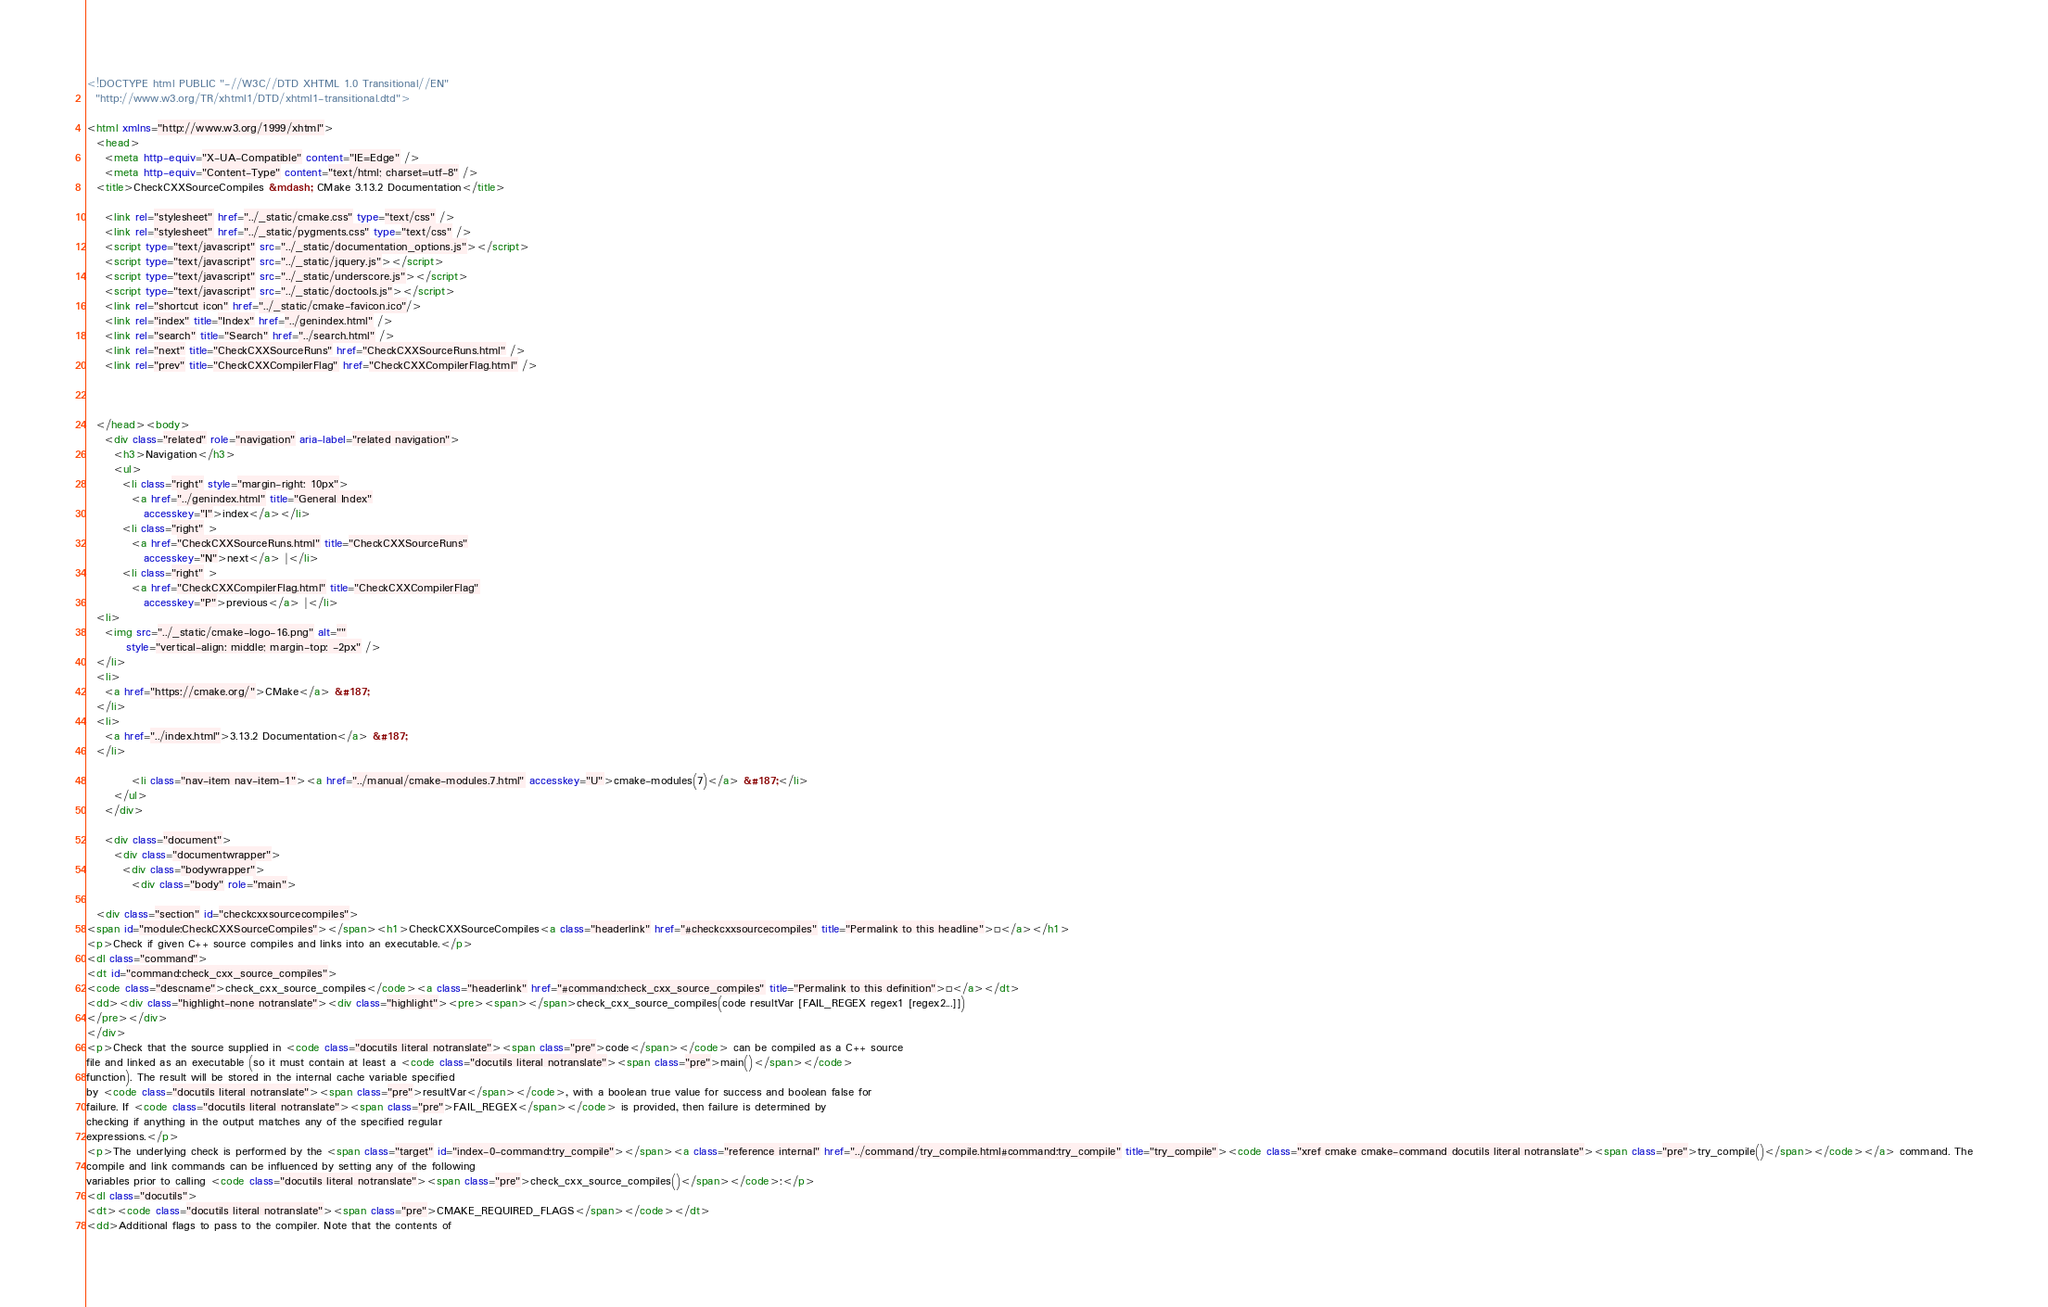Convert code to text. <code><loc_0><loc_0><loc_500><loc_500><_HTML_>
<!DOCTYPE html PUBLIC "-//W3C//DTD XHTML 1.0 Transitional//EN"
  "http://www.w3.org/TR/xhtml1/DTD/xhtml1-transitional.dtd">

<html xmlns="http://www.w3.org/1999/xhtml">
  <head>
    <meta http-equiv="X-UA-Compatible" content="IE=Edge" />
    <meta http-equiv="Content-Type" content="text/html; charset=utf-8" />
  <title>CheckCXXSourceCompiles &mdash; CMake 3.13.2 Documentation</title>

    <link rel="stylesheet" href="../_static/cmake.css" type="text/css" />
    <link rel="stylesheet" href="../_static/pygments.css" type="text/css" />
    <script type="text/javascript" src="../_static/documentation_options.js"></script>
    <script type="text/javascript" src="../_static/jquery.js"></script>
    <script type="text/javascript" src="../_static/underscore.js"></script>
    <script type="text/javascript" src="../_static/doctools.js"></script>
    <link rel="shortcut icon" href="../_static/cmake-favicon.ico"/>
    <link rel="index" title="Index" href="../genindex.html" />
    <link rel="search" title="Search" href="../search.html" />
    <link rel="next" title="CheckCXXSourceRuns" href="CheckCXXSourceRuns.html" />
    <link rel="prev" title="CheckCXXCompilerFlag" href="CheckCXXCompilerFlag.html" />
  
 

  </head><body>
    <div class="related" role="navigation" aria-label="related navigation">
      <h3>Navigation</h3>
      <ul>
        <li class="right" style="margin-right: 10px">
          <a href="../genindex.html" title="General Index"
             accesskey="I">index</a></li>
        <li class="right" >
          <a href="CheckCXXSourceRuns.html" title="CheckCXXSourceRuns"
             accesskey="N">next</a> |</li>
        <li class="right" >
          <a href="CheckCXXCompilerFlag.html" title="CheckCXXCompilerFlag"
             accesskey="P">previous</a> |</li>
  <li>
    <img src="../_static/cmake-logo-16.png" alt=""
         style="vertical-align: middle; margin-top: -2px" />
  </li>
  <li>
    <a href="https://cmake.org/">CMake</a> &#187;
  </li>
  <li>
    <a href="../index.html">3.13.2 Documentation</a> &#187;
  </li>

          <li class="nav-item nav-item-1"><a href="../manual/cmake-modules.7.html" accesskey="U">cmake-modules(7)</a> &#187;</li> 
      </ul>
    </div>  

    <div class="document">
      <div class="documentwrapper">
        <div class="bodywrapper">
          <div class="body" role="main">
            
  <div class="section" id="checkcxxsourcecompiles">
<span id="module:CheckCXXSourceCompiles"></span><h1>CheckCXXSourceCompiles<a class="headerlink" href="#checkcxxsourcecompiles" title="Permalink to this headline">¶</a></h1>
<p>Check if given C++ source compiles and links into an executable.</p>
<dl class="command">
<dt id="command:check_cxx_source_compiles">
<code class="descname">check_cxx_source_compiles</code><a class="headerlink" href="#command:check_cxx_source_compiles" title="Permalink to this definition">¶</a></dt>
<dd><div class="highlight-none notranslate"><div class="highlight"><pre><span></span>check_cxx_source_compiles(code resultVar [FAIL_REGEX regex1 [regex2...]])
</pre></div>
</div>
<p>Check that the source supplied in <code class="docutils literal notranslate"><span class="pre">code</span></code> can be compiled as a C++ source
file and linked as an executable (so it must contain at least a <code class="docutils literal notranslate"><span class="pre">main()</span></code>
function). The result will be stored in the internal cache variable specified
by <code class="docutils literal notranslate"><span class="pre">resultVar</span></code>, with a boolean true value for success and boolean false for
failure. If <code class="docutils literal notranslate"><span class="pre">FAIL_REGEX</span></code> is provided, then failure is determined by
checking if anything in the output matches any of the specified regular
expressions.</p>
<p>The underlying check is performed by the <span class="target" id="index-0-command:try_compile"></span><a class="reference internal" href="../command/try_compile.html#command:try_compile" title="try_compile"><code class="xref cmake cmake-command docutils literal notranslate"><span class="pre">try_compile()</span></code></a> command. The
compile and link commands can be influenced by setting any of the following
variables prior to calling <code class="docutils literal notranslate"><span class="pre">check_cxx_source_compiles()</span></code>:</p>
<dl class="docutils">
<dt><code class="docutils literal notranslate"><span class="pre">CMAKE_REQUIRED_FLAGS</span></code></dt>
<dd>Additional flags to pass to the compiler. Note that the contents of</code> 